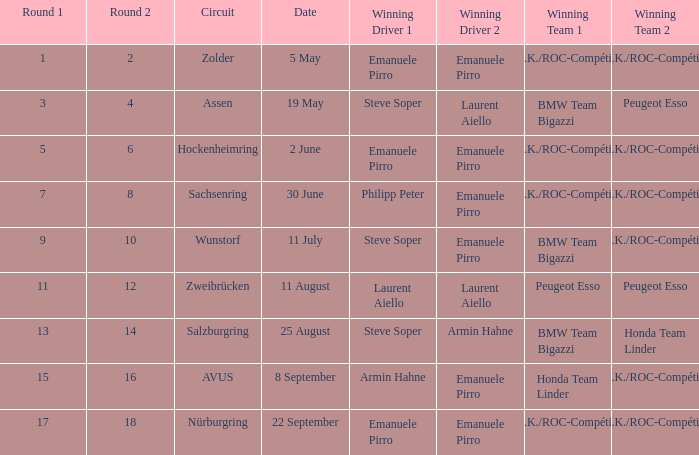Who is the successful driver of the race on 5 may? Emanuele Pirro Emanuele Pirro. 